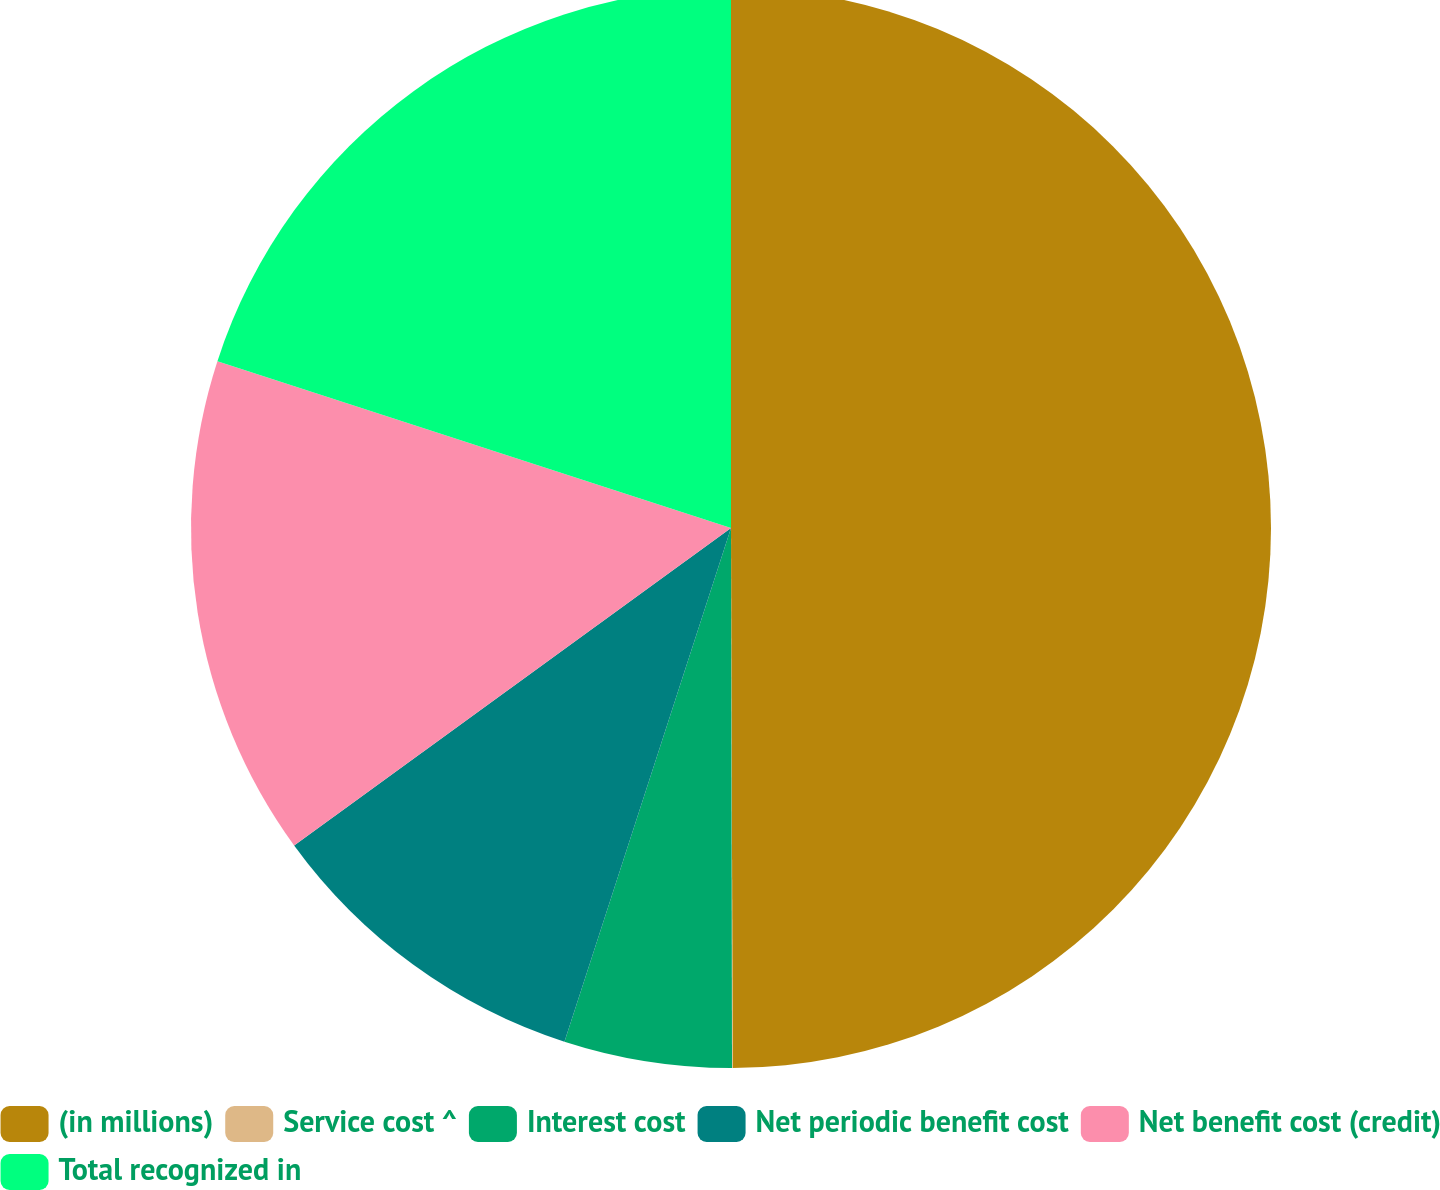<chart> <loc_0><loc_0><loc_500><loc_500><pie_chart><fcel>(in millions)<fcel>Service cost ^<fcel>Interest cost<fcel>Net periodic benefit cost<fcel>Net benefit cost (credit)<fcel>Total recognized in<nl><fcel>49.95%<fcel>0.02%<fcel>5.02%<fcel>10.01%<fcel>15.0%<fcel>20.0%<nl></chart> 